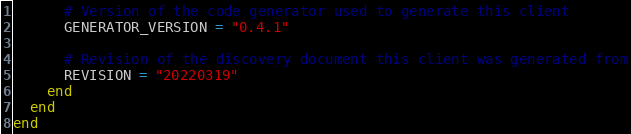Convert code to text. <code><loc_0><loc_0><loc_500><loc_500><_Ruby_>      # Version of the code generator used to generate this client
      GENERATOR_VERSION = "0.4.1"

      # Revision of the discovery document this client was generated from
      REVISION = "20220319"
    end
  end
end
</code> 